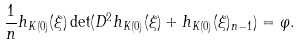<formula> <loc_0><loc_0><loc_500><loc_500>\frac { 1 } { n } h _ { K ( 0 ) } ( \xi ) \det ( D ^ { 2 } h _ { K ( 0 ) } ( \xi ) + h _ { K ( 0 ) } ( \xi ) _ { n - 1 } ) = \varphi .</formula> 